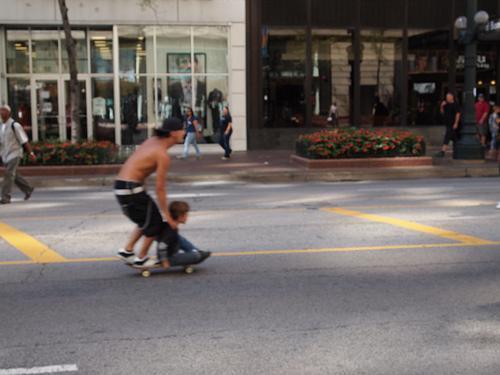How many boys in photo?
Give a very brief answer. 2. 